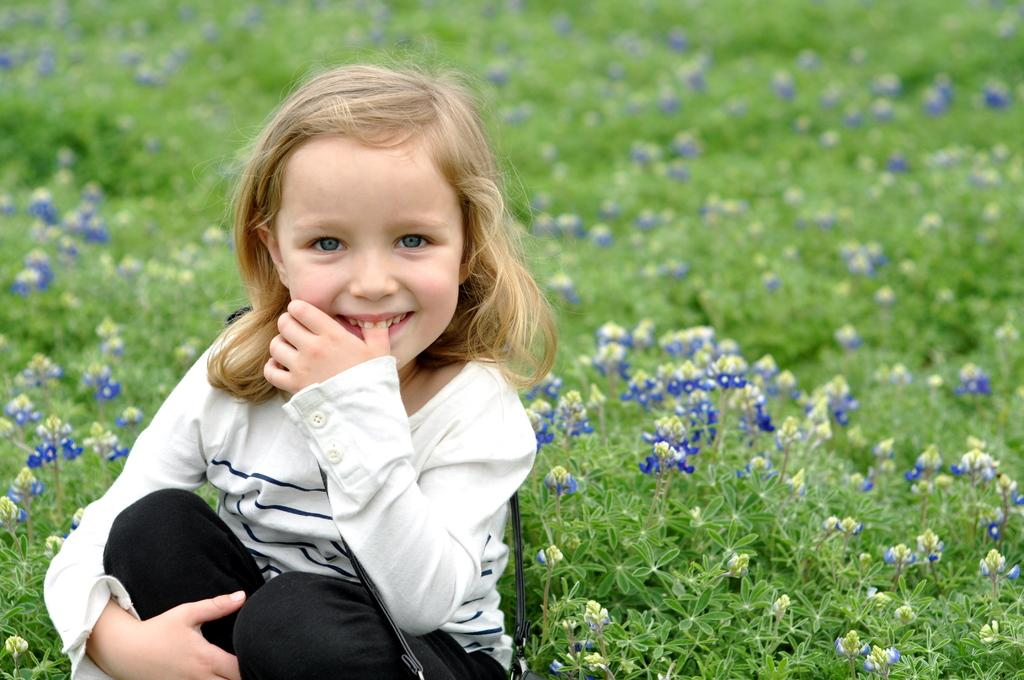What is the main subject of the picture? The main subject of the picture is a kid. What is the kid doing in the picture? The kid is sitting in the picture. What is the kid's facial expression in the picture? The kid is smiling in the picture. What type of vegetation can be seen at the bottom of the image? There are plants at the bottom of the image. What type of flowers are present in the image? There are flowers in the image. What type of pencil can be seen in the kid's hand in the image? There is no pencil present in the image; the kid is not holding anything. 